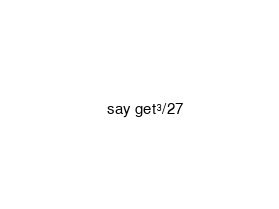<code> <loc_0><loc_0><loc_500><loc_500><_Perl_>say get³/27</code> 